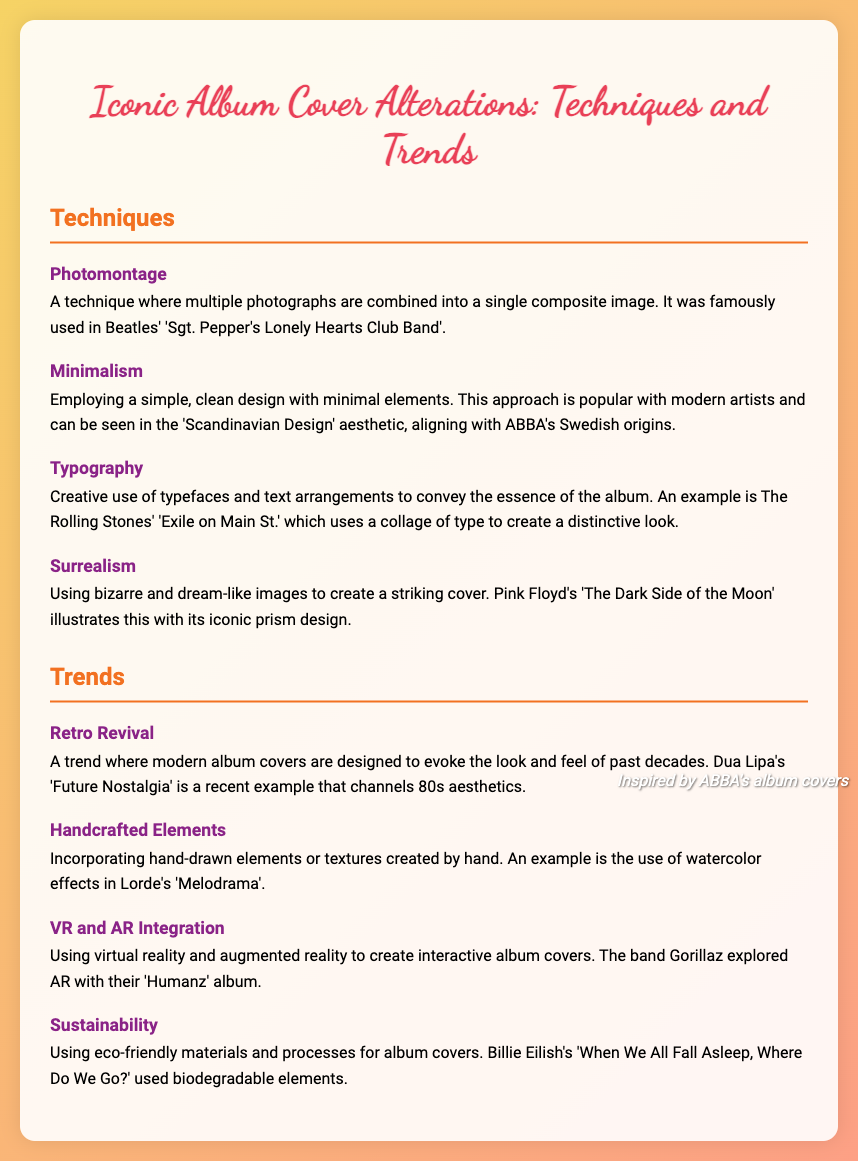What is the first technique listed in the document? The first technique described in the document is mentioned under the Techniques section, which is Photomontage.
Answer: Photomontage Who is an example of an artist that uses the Surrealism technique? The document provides Pink Floyd as an example of an artist known for using the Surrealism technique on their album cover.
Answer: Pink Floyd What trend is characterized by evoking past decades in modern album covers? The document describes Retro Revival as the trend that evokes the look and feel of past decades.
Answer: Retro Revival Which album cover features handcrafted elements? Lorde's album titled 'Melodrama' is noted in the document as having handcrafted elements.
Answer: Melodrama What is the definition of Minimalism in album cover design? The definition of Minimalism is provided in the Techniques section, stating it involves using a simple, clean design with minimal elements.
Answer: A simple, clean design with minimal elements Which artist's album cover used biodegradable elements? The document cites Billie Eilish's album 'When We All Fall Asleep, Where Do We Go?' as an example that used biodegradable elements.
Answer: Billie Eilish What technique is famously used in the Beatles' album? The document indicates that the technique of Photomontage is famously used in the Beatles' 'Sgt. Pepper's Lonely Hearts Club Band'.
Answer: Photomontage What is the last trend mentioned in the document? The document lists Sustainability as the last trend in the Trends section.
Answer: Sustainability 